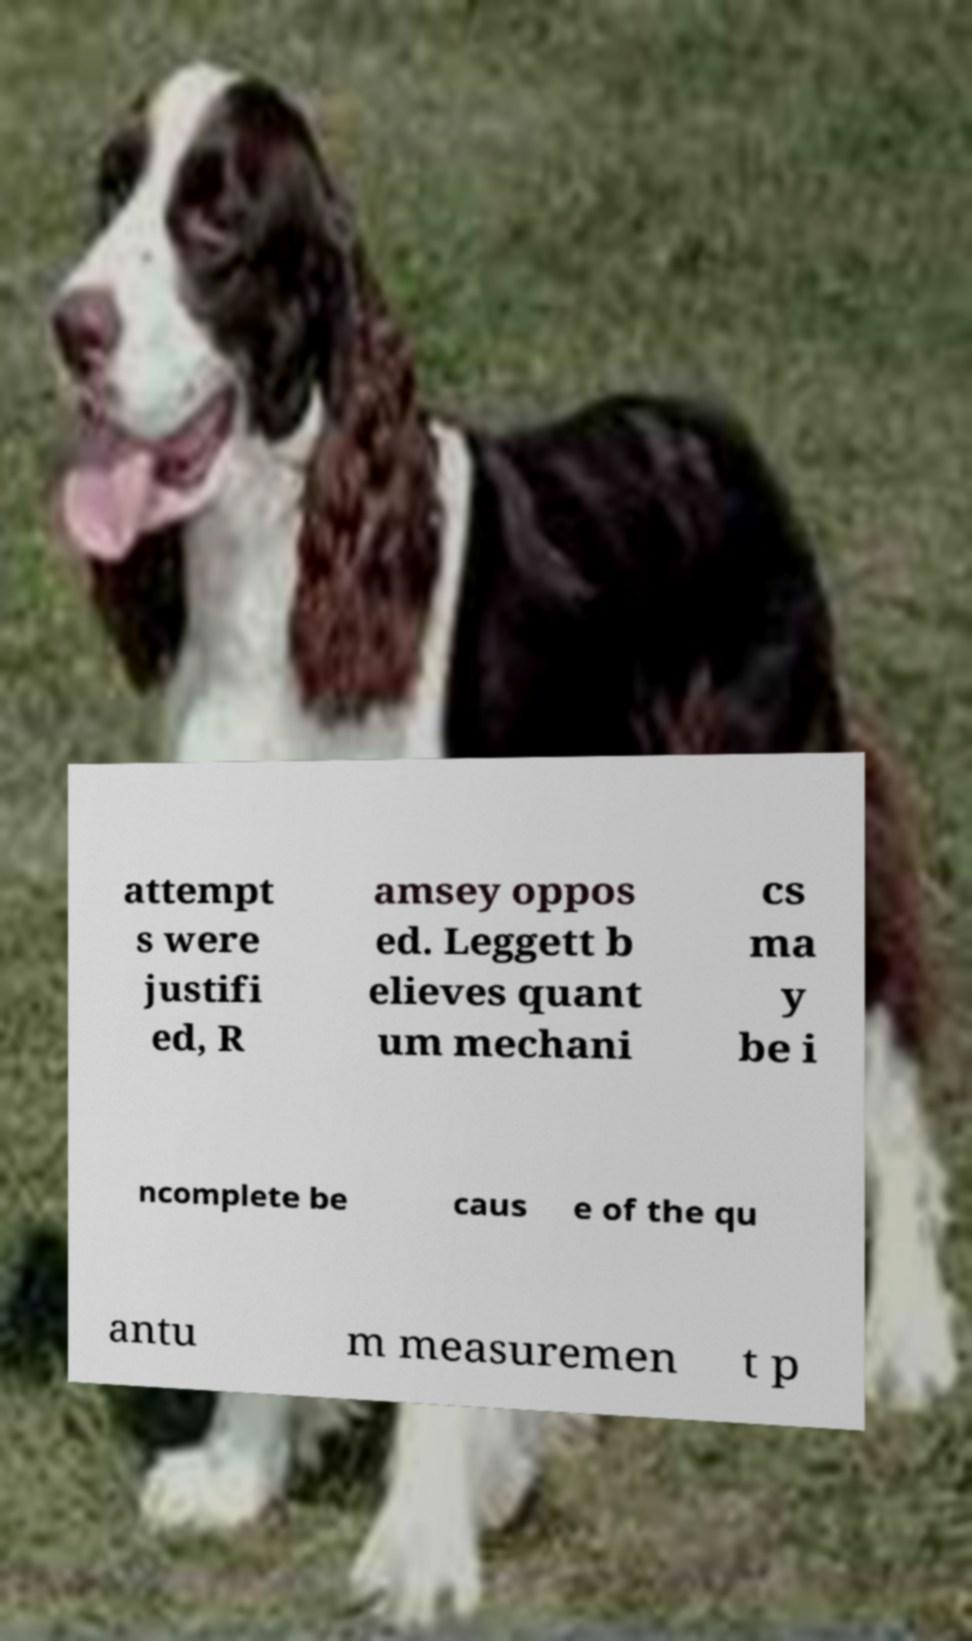Could you assist in decoding the text presented in this image and type it out clearly? attempt s were justifi ed, R amsey oppos ed. Leggett b elieves quant um mechani cs ma y be i ncomplete be caus e of the qu antu m measuremen t p 